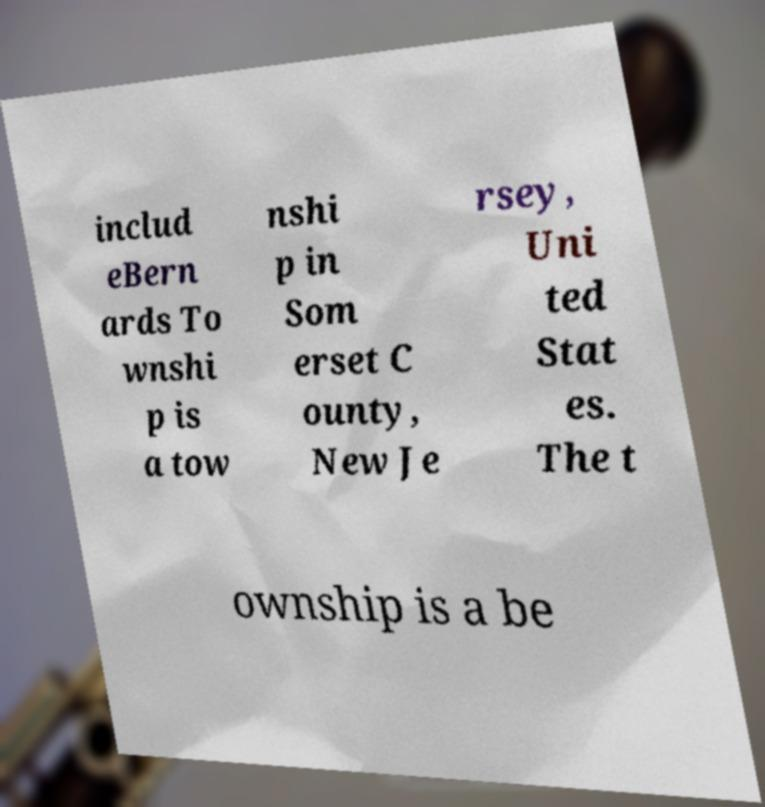Please read and relay the text visible in this image. What does it say? includ eBern ards To wnshi p is a tow nshi p in Som erset C ounty, New Je rsey, Uni ted Stat es. The t ownship is a be 